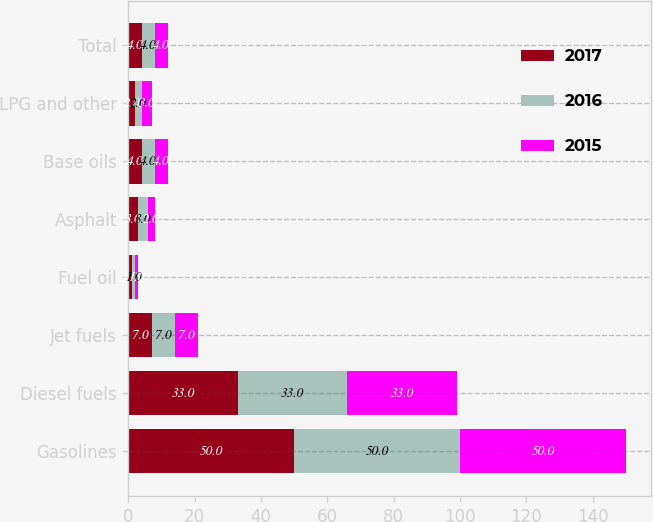Convert chart. <chart><loc_0><loc_0><loc_500><loc_500><stacked_bar_chart><ecel><fcel>Gasolines<fcel>Diesel fuels<fcel>Jet fuels<fcel>Fuel oil<fcel>Asphalt<fcel>Base oils<fcel>LPG and other<fcel>Total<nl><fcel>2017<fcel>50<fcel>33<fcel>7<fcel>1<fcel>3<fcel>4<fcel>2<fcel>4<nl><fcel>2016<fcel>50<fcel>33<fcel>7<fcel>1<fcel>3<fcel>4<fcel>2<fcel>4<nl><fcel>2015<fcel>50<fcel>33<fcel>7<fcel>1<fcel>2<fcel>4<fcel>3<fcel>4<nl></chart> 